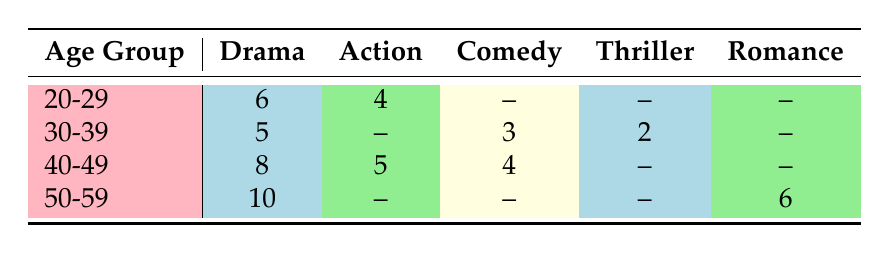What is the total number of nominations for actresses aged 40-49 in Drama? According to the table, the number of nominations for actresses aged 40-49 in Drama is 8.
Answer: 8 Which age group has the highest number of nominations in Action films? The table indicates that for the Action genre, the age group of 40-49 has 5 nominations, while 20-29 has 4, and there are no nominations for ages 30-39 and 50-59. Thus, 40-49 has the highest nominations.
Answer: 40-49 How many nominations does Meryl Streep have in Drama? The table shows that Meryl Streep, who falls in the age group 50-59, has 10 nominations specifically in the Drama genre.
Answer: 10 Is there an age group with nominations in both Comedy and Drama? Referring to the table, the 30-39 age group has nominations in both Comedy (3) and Drama (5), confirming it is true that there is an age group with nominations in both genres.
Answer: Yes What is the average number of nominations for actresses in the age group 20-29 across all film genres? From the table, the nominations for age group 20-29 are 6 in Drama and 4 in Action. There are no nominations in Comedy or other genres, so we sum the nominations (6 + 4 = 10) and divide by the number of genres that have nominations (2), resulting in an average of 10/2 = 5.
Answer: 5 Which actress has the highest nominations and in which genre? Looking at the nominations, Meryl Streep has the highest at 10 in the Drama genre; thus, she is the leading nominee in this table.
Answer: Meryl Streep, Drama Are there any nominations for Thriller in the 20-29 age group? A quick glance at the table shows that the 20-29 age group has no nominations in the Thriller genre as it is marked with a dash, indicating no nominations.
Answer: No How many total nominations are there for the Comedy genre across all age groups? The Comedy genre nominations are 3 from the 30-39 age group and 4 from the 40-49 age group. Therefore, summing these gives us 3 + 4 = 7 total nominations in Comedy.
Answer: 7 